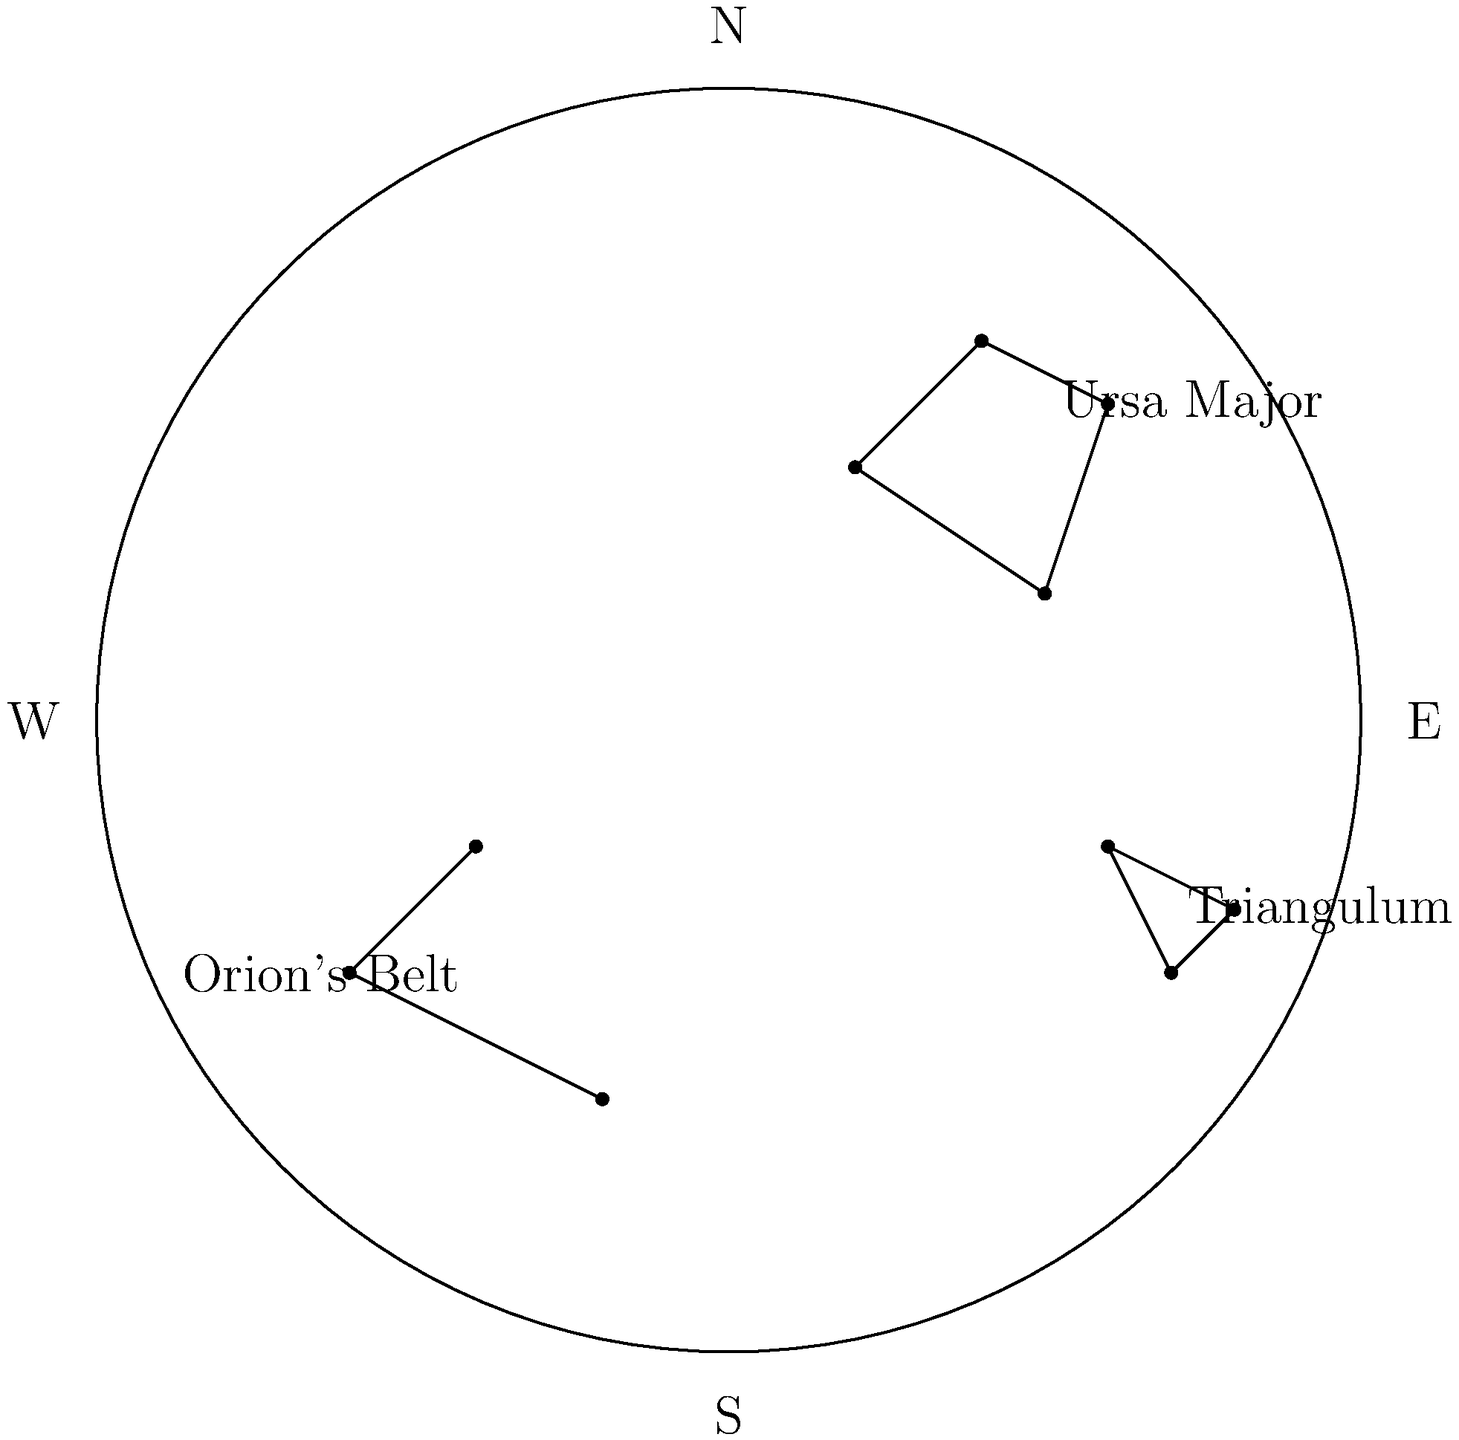Using the provided star chart, which constellation is located in the northeastern quadrant of the sky? To answer this question, we need to follow these steps:

1. Identify the quadrants of the sky chart:
   - North is at the top of the chart
   - South is at the bottom of the chart
   - East is to the right
   - West is to the left

2. Locate the northeastern quadrant:
   - This would be the upper-right quarter of the circular star chart

3. Examine the constellations in the star chart:
   - Ursa Major is in the northern part, slightly towards the east
   - Orion's Belt is in the southwestern quadrant
   - Triangulum is in the eastern part, slightly towards the south

4. Determine which constellation is in the northeastern quadrant:
   - Ursa Major is the only constellation that falls within this quadrant

By following these steps, we can conclude that Ursa Major is the constellation located in the northeastern quadrant of the sky according to the given star chart.
Answer: Ursa Major 